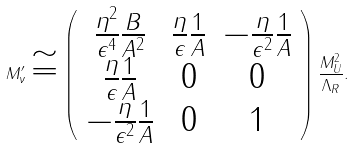<formula> <loc_0><loc_0><loc_500><loc_500>M ^ { \prime } _ { \nu } \cong \left ( \begin{array} { c c c } \frac { \eta ^ { 2 } } { \epsilon ^ { 4 } } \frac { B } { A ^ { 2 } } & \frac { \eta } { \epsilon } \frac { 1 } { A } & - \frac { \eta } { \epsilon ^ { 2 } } \frac { 1 } { A } \\ \frac { \eta } { \epsilon } \frac { 1 } { A } & 0 & 0 \\ - \frac { \eta } { \epsilon ^ { 2 } } \frac { 1 } { A } & 0 & 1 \end{array} \right ) \frac { M _ { U } ^ { 2 } } { \Lambda _ { R } } .</formula> 